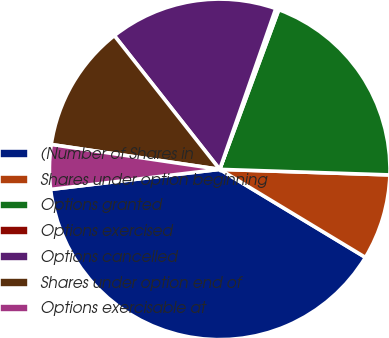<chart> <loc_0><loc_0><loc_500><loc_500><pie_chart><fcel>(Number of Shares in<fcel>Shares under option beginning<fcel>Options granted<fcel>Options exercised<fcel>Options cancelled<fcel>Shares under option end of<fcel>Options exercisable at<nl><fcel>39.47%<fcel>8.13%<fcel>19.88%<fcel>0.3%<fcel>15.96%<fcel>12.05%<fcel>4.21%<nl></chart> 